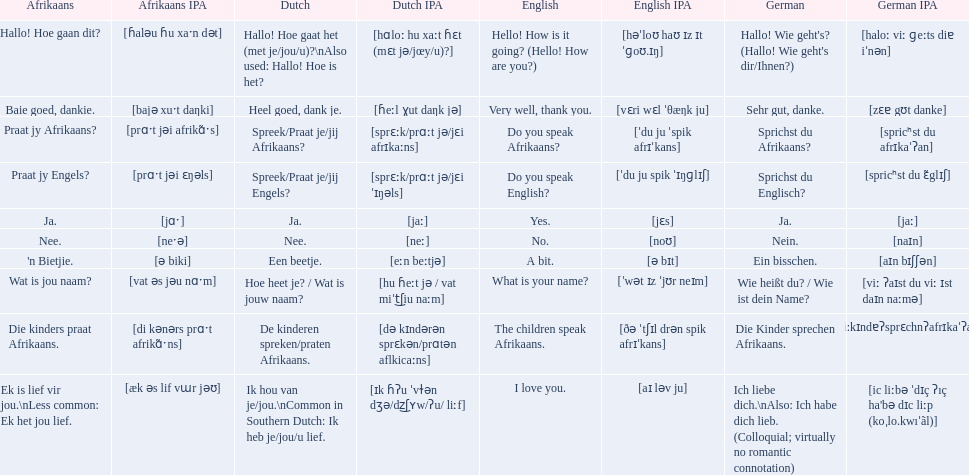How do you say do you speak english in german? Sprichst du Englisch?. What about do you speak afrikaanss? in afrikaans? Praat jy Afrikaans?. 